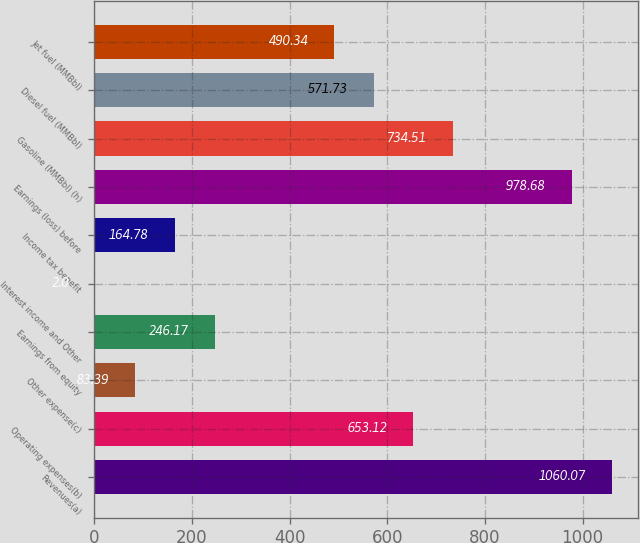Convert chart. <chart><loc_0><loc_0><loc_500><loc_500><bar_chart><fcel>Revenues(a)<fcel>Operating expenses(b)<fcel>Other expense(c)<fcel>Earnings from equity<fcel>Interest income and Other<fcel>Income tax benefit<fcel>Earnings (loss) before<fcel>Gasoline (MMBbl) (h)<fcel>Diesel fuel (MMBbl)<fcel>Jet fuel (MMBbl)<nl><fcel>1060.07<fcel>653.12<fcel>83.39<fcel>246.17<fcel>2<fcel>164.78<fcel>978.68<fcel>734.51<fcel>571.73<fcel>490.34<nl></chart> 